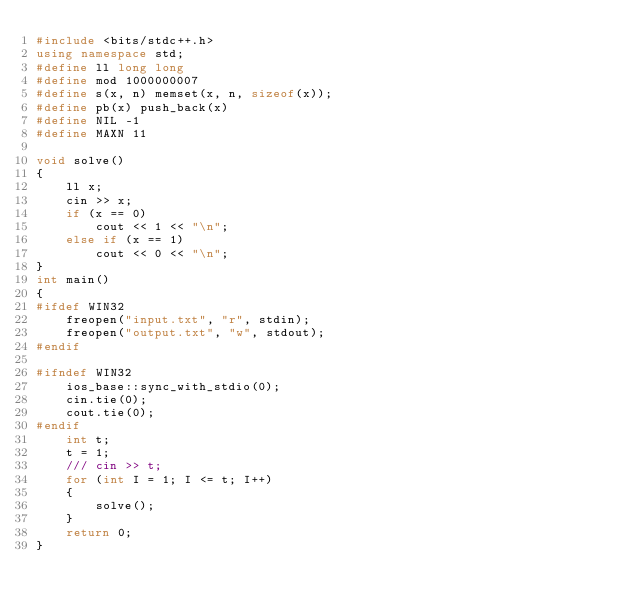<code> <loc_0><loc_0><loc_500><loc_500><_C++_>#include <bits/stdc++.h>
using namespace std;
#define ll long long
#define mod 1000000007
#define s(x, n) memset(x, n, sizeof(x));
#define pb(x) push_back(x)
#define NIL -1
#define MAXN 11

void solve()
{
    ll x;
    cin >> x;
    if (x == 0)
        cout << 1 << "\n";
    else if (x == 1)
        cout << 0 << "\n";
}
int main()
{
#ifdef WIN32
    freopen("input.txt", "r", stdin);
    freopen("output.txt", "w", stdout);
#endif

#ifndef WIN32
    ios_base::sync_with_stdio(0);
    cin.tie(0);
    cout.tie(0);
#endif
    int t;
    t = 1;
    /// cin >> t;
    for (int I = 1; I <= t; I++)
    {
        solve();
    }
    return 0;
}
</code> 